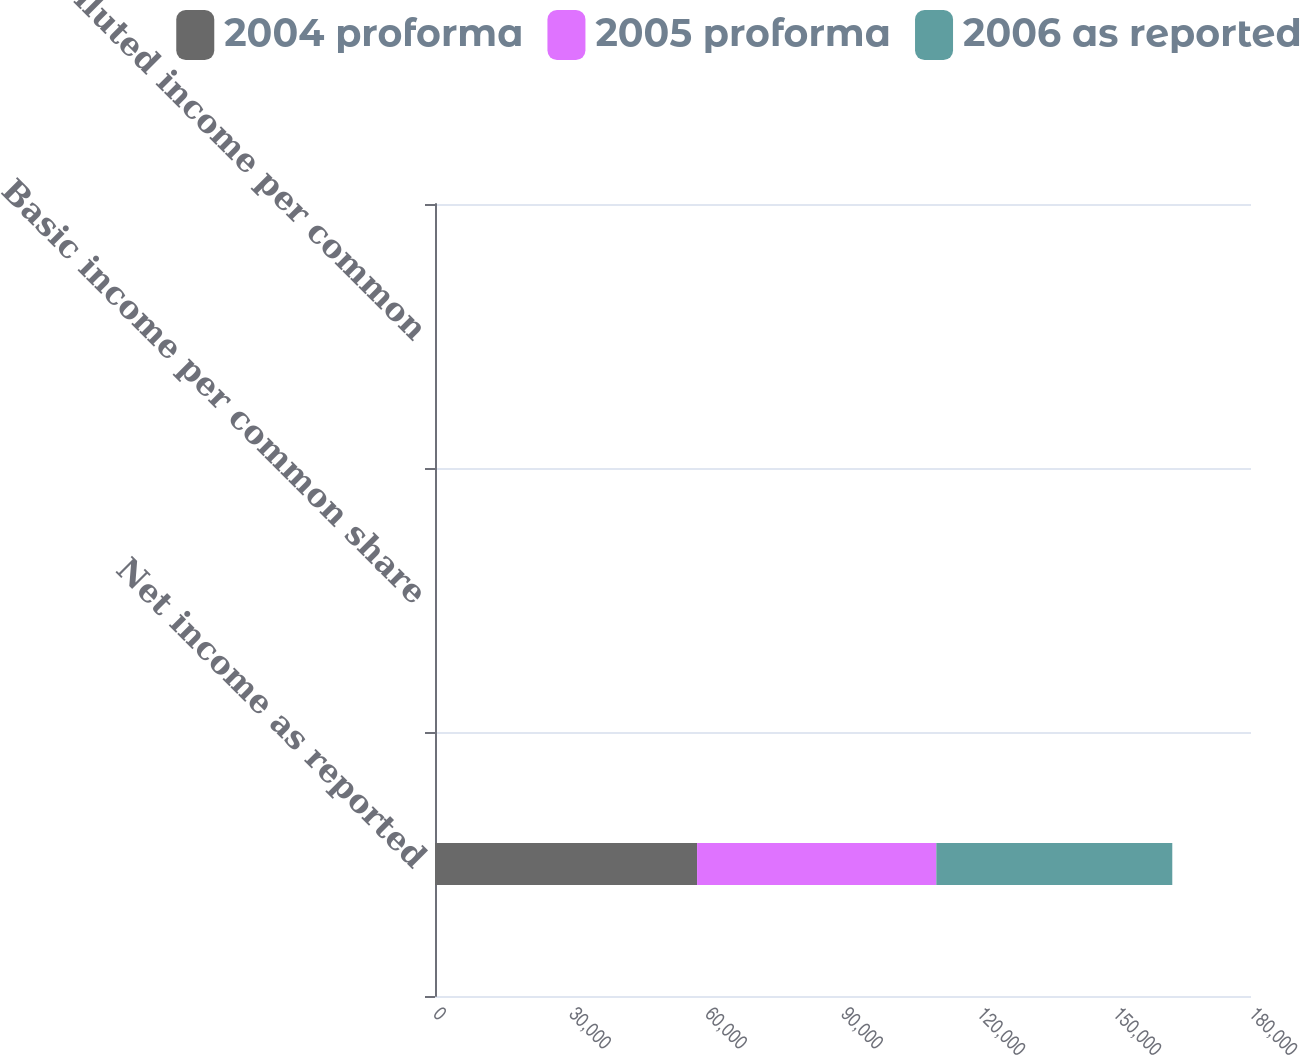<chart> <loc_0><loc_0><loc_500><loc_500><stacked_bar_chart><ecel><fcel>Net income as reported<fcel>Basic income per common share<fcel>Diluted income per common<nl><fcel>2004 proforma<fcel>57809<fcel>0.86<fcel>0.84<nl><fcel>2005 proforma<fcel>52773<fcel>0.78<fcel>0.76<nl><fcel>2006 as reported<fcel>52055<fcel>0.76<fcel>0.74<nl></chart> 